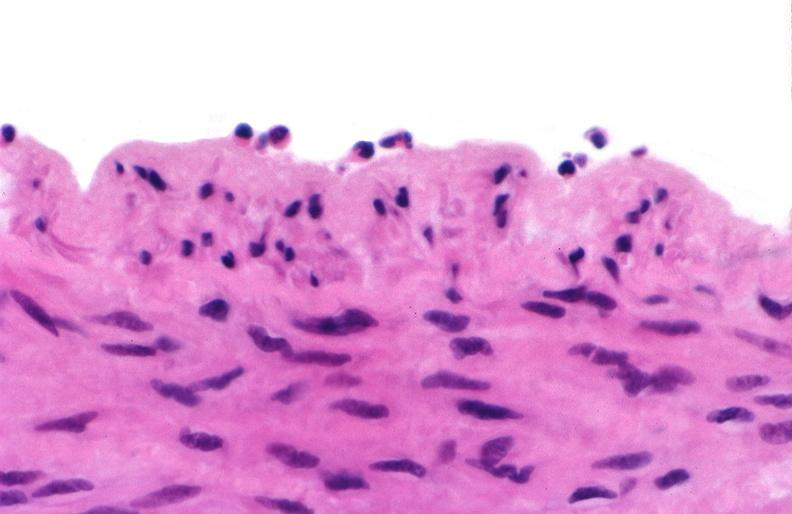s vasculature present?
Answer the question using a single word or phrase. Yes 